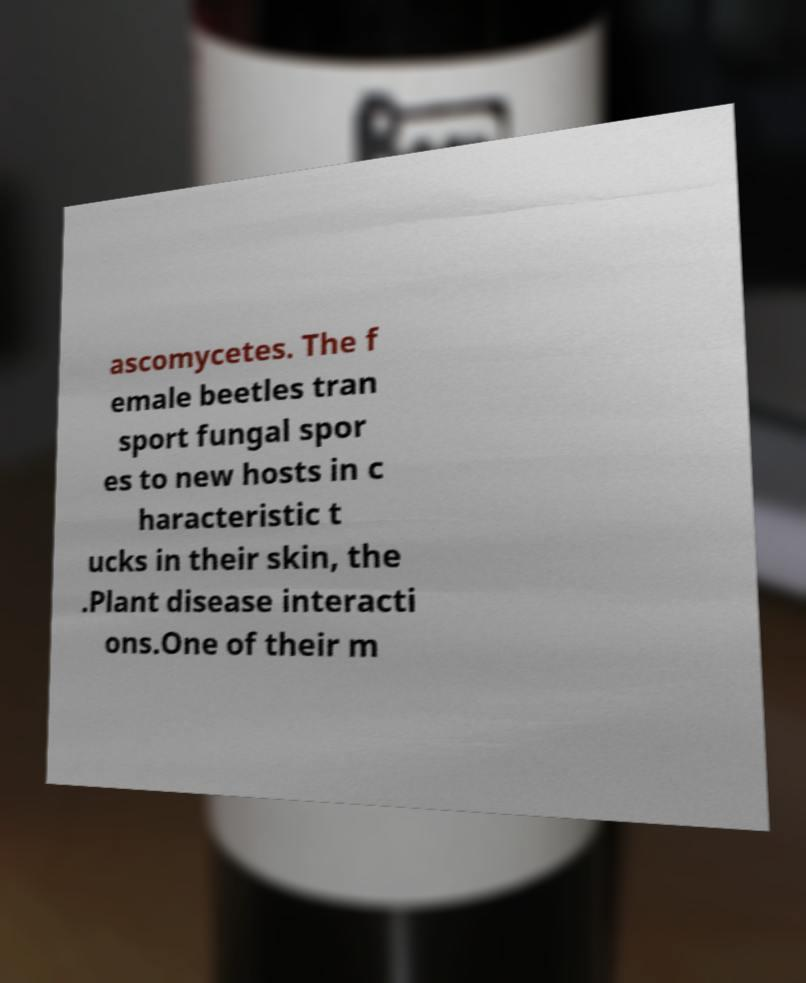Please read and relay the text visible in this image. What does it say? ascomycetes. The f emale beetles tran sport fungal spor es to new hosts in c haracteristic t ucks in their skin, the .Plant disease interacti ons.One of their m 